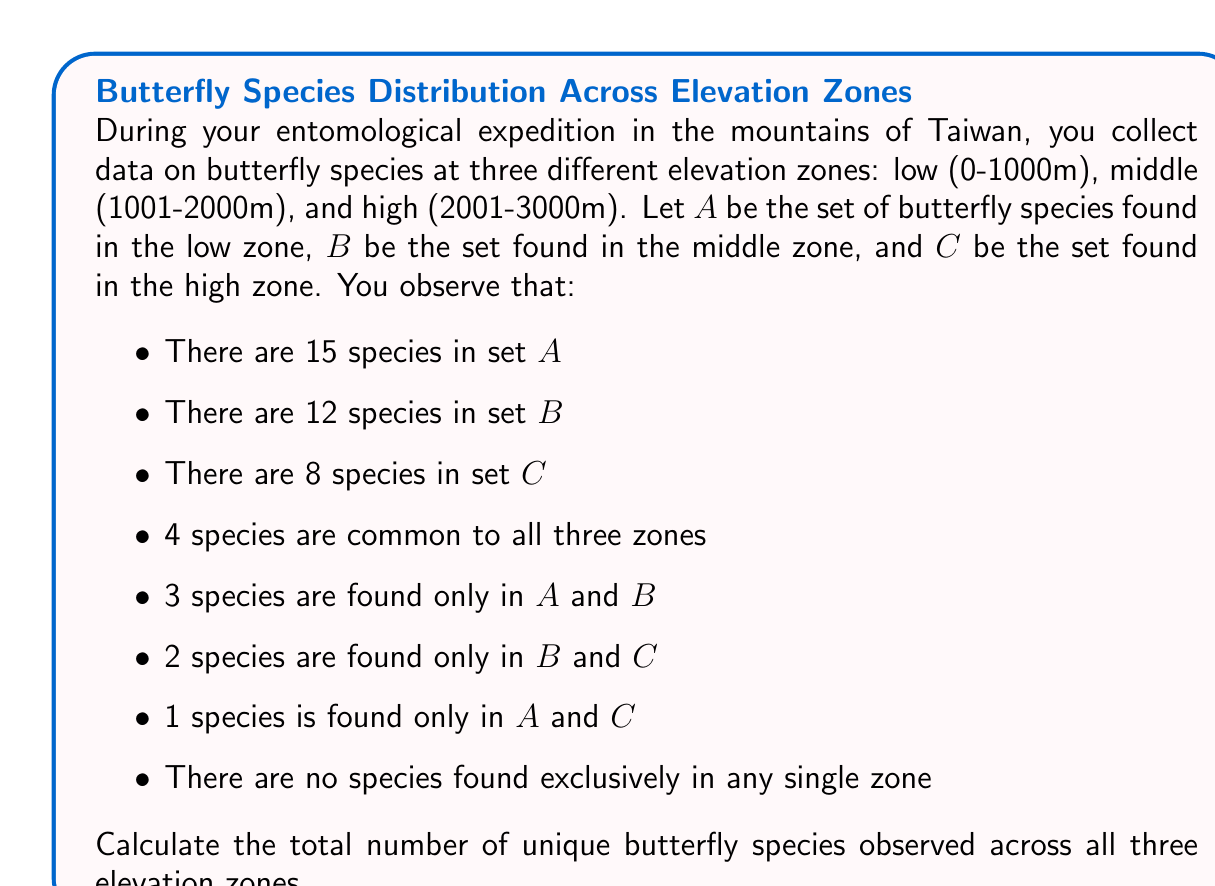Can you answer this question? To solve this problem, we'll use the principle of inclusion-exclusion for three sets. Let's break it down step by step:

1) First, let's define our universe U as the set of all butterfly species observed across all zones. We need to find |U|.

2) The principle of inclusion-exclusion for three sets states:

   $$|A \cup B \cup C| = |A| + |B| + |C| - |A \cap B| - |B \cap C| - |A \cap C| + |A \cap B \cap C|$$

3) We're given:
   - |A| = 15
   - |B| = 12
   - |C| = 8
   - |A ∩ B ∩ C| = 4

4) We need to calculate |A ∩ B|, |B ∩ C|, and |A ∩ C|:

   - |A ∩ B| = 4 (common to all) + 3 (only in A and B) = 7
   - |B ∩ C| = 4 (common to all) + 2 (only in B and C) = 6
   - |A ∩ C| = 4 (common to all) + 1 (only in A and C) = 5

5) Now we can plug these values into our equation:

   $$|U| = 15 + 12 + 8 - 7 - 6 - 5 + 4 = 21$$

Therefore, the total number of unique butterfly species observed across all three elevation zones is 21.
Answer: 21 unique butterfly species 